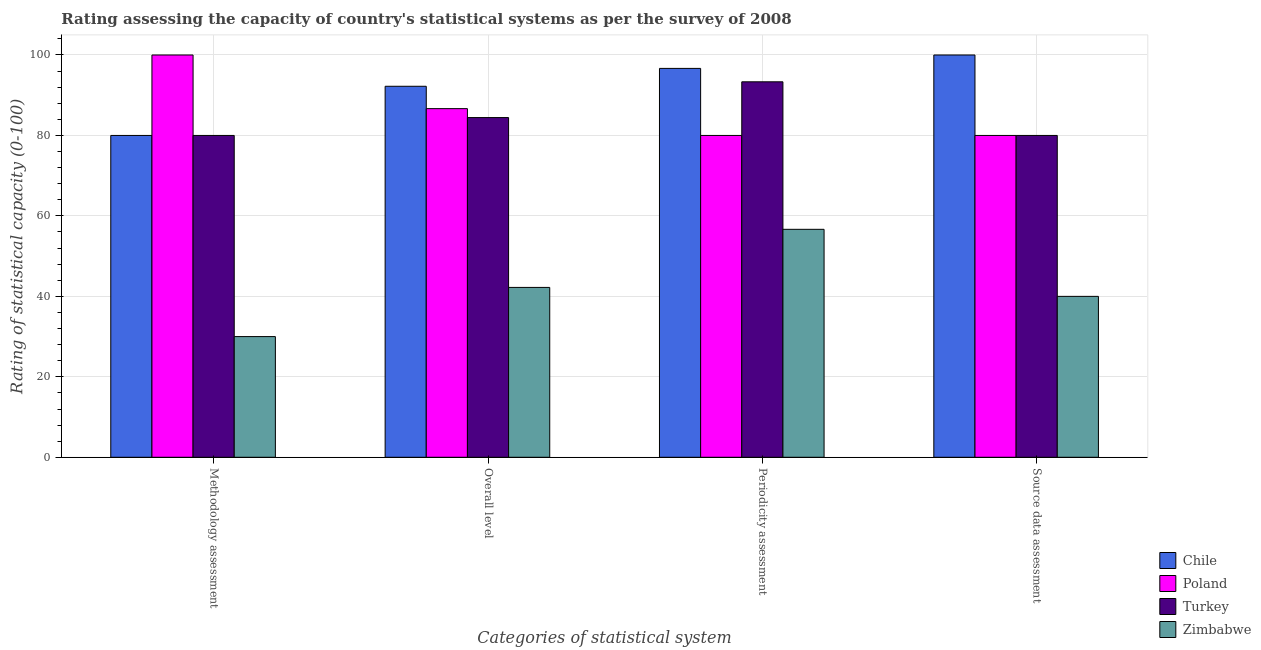How many different coloured bars are there?
Your answer should be compact. 4. How many groups of bars are there?
Your answer should be compact. 4. Are the number of bars on each tick of the X-axis equal?
Offer a very short reply. Yes. How many bars are there on the 4th tick from the left?
Your answer should be compact. 4. How many bars are there on the 1st tick from the right?
Make the answer very short. 4. What is the label of the 2nd group of bars from the left?
Your answer should be very brief. Overall level. What is the overall level rating in Chile?
Offer a terse response. 92.22. Across all countries, what is the maximum source data assessment rating?
Make the answer very short. 100. Across all countries, what is the minimum periodicity assessment rating?
Give a very brief answer. 56.67. In which country was the methodology assessment rating maximum?
Provide a succinct answer. Poland. In which country was the periodicity assessment rating minimum?
Your answer should be very brief. Zimbabwe. What is the total periodicity assessment rating in the graph?
Provide a short and direct response. 326.67. What is the difference between the periodicity assessment rating in Poland and that in Turkey?
Ensure brevity in your answer.  -13.33. What is the average methodology assessment rating per country?
Offer a very short reply. 72.5. What is the difference between the periodicity assessment rating and overall level rating in Chile?
Provide a succinct answer. 4.44. What is the ratio of the overall level rating in Chile to that in Zimbabwe?
Your response must be concise. 2.18. Is the difference between the periodicity assessment rating in Chile and Turkey greater than the difference between the source data assessment rating in Chile and Turkey?
Offer a terse response. No. What is the difference between the highest and the lowest methodology assessment rating?
Offer a terse response. 70. Is it the case that in every country, the sum of the overall level rating and source data assessment rating is greater than the sum of methodology assessment rating and periodicity assessment rating?
Provide a short and direct response. No. What does the 2nd bar from the left in Source data assessment represents?
Your answer should be very brief. Poland. What does the 3rd bar from the right in Periodicity assessment represents?
Your answer should be very brief. Poland. Is it the case that in every country, the sum of the methodology assessment rating and overall level rating is greater than the periodicity assessment rating?
Your answer should be compact. Yes. How many bars are there?
Your response must be concise. 16. Are all the bars in the graph horizontal?
Your answer should be very brief. No. How many countries are there in the graph?
Provide a short and direct response. 4. What is the difference between two consecutive major ticks on the Y-axis?
Your answer should be compact. 20. How are the legend labels stacked?
Keep it short and to the point. Vertical. What is the title of the graph?
Offer a terse response. Rating assessing the capacity of country's statistical systems as per the survey of 2008 . What is the label or title of the X-axis?
Make the answer very short. Categories of statistical system. What is the label or title of the Y-axis?
Offer a terse response. Rating of statistical capacity (0-100). What is the Rating of statistical capacity (0-100) of Chile in Methodology assessment?
Provide a short and direct response. 80. What is the Rating of statistical capacity (0-100) in Zimbabwe in Methodology assessment?
Give a very brief answer. 30. What is the Rating of statistical capacity (0-100) of Chile in Overall level?
Provide a short and direct response. 92.22. What is the Rating of statistical capacity (0-100) of Poland in Overall level?
Your answer should be compact. 86.67. What is the Rating of statistical capacity (0-100) in Turkey in Overall level?
Provide a succinct answer. 84.44. What is the Rating of statistical capacity (0-100) in Zimbabwe in Overall level?
Offer a very short reply. 42.22. What is the Rating of statistical capacity (0-100) in Chile in Periodicity assessment?
Provide a short and direct response. 96.67. What is the Rating of statistical capacity (0-100) of Turkey in Periodicity assessment?
Your answer should be compact. 93.33. What is the Rating of statistical capacity (0-100) of Zimbabwe in Periodicity assessment?
Make the answer very short. 56.67. What is the Rating of statistical capacity (0-100) of Chile in Source data assessment?
Keep it short and to the point. 100. What is the Rating of statistical capacity (0-100) in Turkey in Source data assessment?
Keep it short and to the point. 80. Across all Categories of statistical system, what is the maximum Rating of statistical capacity (0-100) of Chile?
Your response must be concise. 100. Across all Categories of statistical system, what is the maximum Rating of statistical capacity (0-100) of Poland?
Ensure brevity in your answer.  100. Across all Categories of statistical system, what is the maximum Rating of statistical capacity (0-100) in Turkey?
Offer a very short reply. 93.33. Across all Categories of statistical system, what is the maximum Rating of statistical capacity (0-100) in Zimbabwe?
Offer a terse response. 56.67. Across all Categories of statistical system, what is the minimum Rating of statistical capacity (0-100) in Turkey?
Provide a succinct answer. 80. What is the total Rating of statistical capacity (0-100) in Chile in the graph?
Provide a short and direct response. 368.89. What is the total Rating of statistical capacity (0-100) in Poland in the graph?
Provide a short and direct response. 346.67. What is the total Rating of statistical capacity (0-100) of Turkey in the graph?
Offer a terse response. 337.78. What is the total Rating of statistical capacity (0-100) of Zimbabwe in the graph?
Your answer should be very brief. 168.89. What is the difference between the Rating of statistical capacity (0-100) of Chile in Methodology assessment and that in Overall level?
Provide a succinct answer. -12.22. What is the difference between the Rating of statistical capacity (0-100) in Poland in Methodology assessment and that in Overall level?
Ensure brevity in your answer.  13.33. What is the difference between the Rating of statistical capacity (0-100) in Turkey in Methodology assessment and that in Overall level?
Your answer should be very brief. -4.44. What is the difference between the Rating of statistical capacity (0-100) of Zimbabwe in Methodology assessment and that in Overall level?
Your response must be concise. -12.22. What is the difference between the Rating of statistical capacity (0-100) in Chile in Methodology assessment and that in Periodicity assessment?
Provide a short and direct response. -16.67. What is the difference between the Rating of statistical capacity (0-100) of Turkey in Methodology assessment and that in Periodicity assessment?
Keep it short and to the point. -13.33. What is the difference between the Rating of statistical capacity (0-100) in Zimbabwe in Methodology assessment and that in Periodicity assessment?
Your answer should be compact. -26.67. What is the difference between the Rating of statistical capacity (0-100) in Chile in Methodology assessment and that in Source data assessment?
Make the answer very short. -20. What is the difference between the Rating of statistical capacity (0-100) of Poland in Methodology assessment and that in Source data assessment?
Provide a short and direct response. 20. What is the difference between the Rating of statistical capacity (0-100) of Chile in Overall level and that in Periodicity assessment?
Provide a short and direct response. -4.44. What is the difference between the Rating of statistical capacity (0-100) in Turkey in Overall level and that in Periodicity assessment?
Your answer should be compact. -8.89. What is the difference between the Rating of statistical capacity (0-100) of Zimbabwe in Overall level and that in Periodicity assessment?
Provide a short and direct response. -14.44. What is the difference between the Rating of statistical capacity (0-100) in Chile in Overall level and that in Source data assessment?
Provide a succinct answer. -7.78. What is the difference between the Rating of statistical capacity (0-100) in Turkey in Overall level and that in Source data assessment?
Offer a very short reply. 4.44. What is the difference between the Rating of statistical capacity (0-100) in Zimbabwe in Overall level and that in Source data assessment?
Keep it short and to the point. 2.22. What is the difference between the Rating of statistical capacity (0-100) in Chile in Periodicity assessment and that in Source data assessment?
Keep it short and to the point. -3.33. What is the difference between the Rating of statistical capacity (0-100) of Poland in Periodicity assessment and that in Source data assessment?
Provide a short and direct response. 0. What is the difference between the Rating of statistical capacity (0-100) in Turkey in Periodicity assessment and that in Source data assessment?
Provide a succinct answer. 13.33. What is the difference between the Rating of statistical capacity (0-100) in Zimbabwe in Periodicity assessment and that in Source data assessment?
Provide a succinct answer. 16.67. What is the difference between the Rating of statistical capacity (0-100) in Chile in Methodology assessment and the Rating of statistical capacity (0-100) in Poland in Overall level?
Provide a succinct answer. -6.67. What is the difference between the Rating of statistical capacity (0-100) in Chile in Methodology assessment and the Rating of statistical capacity (0-100) in Turkey in Overall level?
Ensure brevity in your answer.  -4.44. What is the difference between the Rating of statistical capacity (0-100) in Chile in Methodology assessment and the Rating of statistical capacity (0-100) in Zimbabwe in Overall level?
Provide a succinct answer. 37.78. What is the difference between the Rating of statistical capacity (0-100) in Poland in Methodology assessment and the Rating of statistical capacity (0-100) in Turkey in Overall level?
Offer a very short reply. 15.56. What is the difference between the Rating of statistical capacity (0-100) in Poland in Methodology assessment and the Rating of statistical capacity (0-100) in Zimbabwe in Overall level?
Your answer should be very brief. 57.78. What is the difference between the Rating of statistical capacity (0-100) in Turkey in Methodology assessment and the Rating of statistical capacity (0-100) in Zimbabwe in Overall level?
Your response must be concise. 37.78. What is the difference between the Rating of statistical capacity (0-100) in Chile in Methodology assessment and the Rating of statistical capacity (0-100) in Poland in Periodicity assessment?
Your answer should be very brief. 0. What is the difference between the Rating of statistical capacity (0-100) of Chile in Methodology assessment and the Rating of statistical capacity (0-100) of Turkey in Periodicity assessment?
Keep it short and to the point. -13.33. What is the difference between the Rating of statistical capacity (0-100) in Chile in Methodology assessment and the Rating of statistical capacity (0-100) in Zimbabwe in Periodicity assessment?
Your response must be concise. 23.33. What is the difference between the Rating of statistical capacity (0-100) in Poland in Methodology assessment and the Rating of statistical capacity (0-100) in Turkey in Periodicity assessment?
Give a very brief answer. 6.67. What is the difference between the Rating of statistical capacity (0-100) in Poland in Methodology assessment and the Rating of statistical capacity (0-100) in Zimbabwe in Periodicity assessment?
Give a very brief answer. 43.33. What is the difference between the Rating of statistical capacity (0-100) in Turkey in Methodology assessment and the Rating of statistical capacity (0-100) in Zimbabwe in Periodicity assessment?
Give a very brief answer. 23.33. What is the difference between the Rating of statistical capacity (0-100) in Chile in Methodology assessment and the Rating of statistical capacity (0-100) in Poland in Source data assessment?
Provide a short and direct response. 0. What is the difference between the Rating of statistical capacity (0-100) of Chile in Methodology assessment and the Rating of statistical capacity (0-100) of Turkey in Source data assessment?
Make the answer very short. 0. What is the difference between the Rating of statistical capacity (0-100) of Poland in Methodology assessment and the Rating of statistical capacity (0-100) of Turkey in Source data assessment?
Offer a terse response. 20. What is the difference between the Rating of statistical capacity (0-100) of Poland in Methodology assessment and the Rating of statistical capacity (0-100) of Zimbabwe in Source data assessment?
Your response must be concise. 60. What is the difference between the Rating of statistical capacity (0-100) in Chile in Overall level and the Rating of statistical capacity (0-100) in Poland in Periodicity assessment?
Ensure brevity in your answer.  12.22. What is the difference between the Rating of statistical capacity (0-100) in Chile in Overall level and the Rating of statistical capacity (0-100) in Turkey in Periodicity assessment?
Your answer should be compact. -1.11. What is the difference between the Rating of statistical capacity (0-100) of Chile in Overall level and the Rating of statistical capacity (0-100) of Zimbabwe in Periodicity assessment?
Offer a very short reply. 35.56. What is the difference between the Rating of statistical capacity (0-100) in Poland in Overall level and the Rating of statistical capacity (0-100) in Turkey in Periodicity assessment?
Provide a short and direct response. -6.67. What is the difference between the Rating of statistical capacity (0-100) in Poland in Overall level and the Rating of statistical capacity (0-100) in Zimbabwe in Periodicity assessment?
Offer a terse response. 30. What is the difference between the Rating of statistical capacity (0-100) in Turkey in Overall level and the Rating of statistical capacity (0-100) in Zimbabwe in Periodicity assessment?
Offer a very short reply. 27.78. What is the difference between the Rating of statistical capacity (0-100) in Chile in Overall level and the Rating of statistical capacity (0-100) in Poland in Source data assessment?
Your response must be concise. 12.22. What is the difference between the Rating of statistical capacity (0-100) in Chile in Overall level and the Rating of statistical capacity (0-100) in Turkey in Source data assessment?
Provide a short and direct response. 12.22. What is the difference between the Rating of statistical capacity (0-100) in Chile in Overall level and the Rating of statistical capacity (0-100) in Zimbabwe in Source data assessment?
Your answer should be very brief. 52.22. What is the difference between the Rating of statistical capacity (0-100) in Poland in Overall level and the Rating of statistical capacity (0-100) in Turkey in Source data assessment?
Keep it short and to the point. 6.67. What is the difference between the Rating of statistical capacity (0-100) of Poland in Overall level and the Rating of statistical capacity (0-100) of Zimbabwe in Source data assessment?
Ensure brevity in your answer.  46.67. What is the difference between the Rating of statistical capacity (0-100) of Turkey in Overall level and the Rating of statistical capacity (0-100) of Zimbabwe in Source data assessment?
Ensure brevity in your answer.  44.44. What is the difference between the Rating of statistical capacity (0-100) of Chile in Periodicity assessment and the Rating of statistical capacity (0-100) of Poland in Source data assessment?
Give a very brief answer. 16.67. What is the difference between the Rating of statistical capacity (0-100) in Chile in Periodicity assessment and the Rating of statistical capacity (0-100) in Turkey in Source data assessment?
Your response must be concise. 16.67. What is the difference between the Rating of statistical capacity (0-100) of Chile in Periodicity assessment and the Rating of statistical capacity (0-100) of Zimbabwe in Source data assessment?
Your answer should be compact. 56.67. What is the difference between the Rating of statistical capacity (0-100) of Poland in Periodicity assessment and the Rating of statistical capacity (0-100) of Turkey in Source data assessment?
Provide a succinct answer. 0. What is the difference between the Rating of statistical capacity (0-100) of Poland in Periodicity assessment and the Rating of statistical capacity (0-100) of Zimbabwe in Source data assessment?
Your answer should be compact. 40. What is the difference between the Rating of statistical capacity (0-100) in Turkey in Periodicity assessment and the Rating of statistical capacity (0-100) in Zimbabwe in Source data assessment?
Provide a succinct answer. 53.33. What is the average Rating of statistical capacity (0-100) of Chile per Categories of statistical system?
Your answer should be very brief. 92.22. What is the average Rating of statistical capacity (0-100) of Poland per Categories of statistical system?
Keep it short and to the point. 86.67. What is the average Rating of statistical capacity (0-100) in Turkey per Categories of statistical system?
Ensure brevity in your answer.  84.44. What is the average Rating of statistical capacity (0-100) of Zimbabwe per Categories of statistical system?
Your answer should be very brief. 42.22. What is the difference between the Rating of statistical capacity (0-100) in Chile and Rating of statistical capacity (0-100) in Turkey in Methodology assessment?
Ensure brevity in your answer.  0. What is the difference between the Rating of statistical capacity (0-100) of Chile and Rating of statistical capacity (0-100) of Zimbabwe in Methodology assessment?
Provide a succinct answer. 50. What is the difference between the Rating of statistical capacity (0-100) of Chile and Rating of statistical capacity (0-100) of Poland in Overall level?
Provide a succinct answer. 5.56. What is the difference between the Rating of statistical capacity (0-100) in Chile and Rating of statistical capacity (0-100) in Turkey in Overall level?
Your answer should be very brief. 7.78. What is the difference between the Rating of statistical capacity (0-100) of Chile and Rating of statistical capacity (0-100) of Zimbabwe in Overall level?
Make the answer very short. 50. What is the difference between the Rating of statistical capacity (0-100) of Poland and Rating of statistical capacity (0-100) of Turkey in Overall level?
Your answer should be very brief. 2.22. What is the difference between the Rating of statistical capacity (0-100) in Poland and Rating of statistical capacity (0-100) in Zimbabwe in Overall level?
Give a very brief answer. 44.44. What is the difference between the Rating of statistical capacity (0-100) of Turkey and Rating of statistical capacity (0-100) of Zimbabwe in Overall level?
Your response must be concise. 42.22. What is the difference between the Rating of statistical capacity (0-100) of Chile and Rating of statistical capacity (0-100) of Poland in Periodicity assessment?
Make the answer very short. 16.67. What is the difference between the Rating of statistical capacity (0-100) in Poland and Rating of statistical capacity (0-100) in Turkey in Periodicity assessment?
Ensure brevity in your answer.  -13.33. What is the difference between the Rating of statistical capacity (0-100) in Poland and Rating of statistical capacity (0-100) in Zimbabwe in Periodicity assessment?
Offer a very short reply. 23.33. What is the difference between the Rating of statistical capacity (0-100) of Turkey and Rating of statistical capacity (0-100) of Zimbabwe in Periodicity assessment?
Provide a succinct answer. 36.67. What is the difference between the Rating of statistical capacity (0-100) in Chile and Rating of statistical capacity (0-100) in Poland in Source data assessment?
Keep it short and to the point. 20. What is the difference between the Rating of statistical capacity (0-100) of Poland and Rating of statistical capacity (0-100) of Turkey in Source data assessment?
Offer a very short reply. 0. What is the ratio of the Rating of statistical capacity (0-100) in Chile in Methodology assessment to that in Overall level?
Make the answer very short. 0.87. What is the ratio of the Rating of statistical capacity (0-100) of Poland in Methodology assessment to that in Overall level?
Make the answer very short. 1.15. What is the ratio of the Rating of statistical capacity (0-100) in Turkey in Methodology assessment to that in Overall level?
Give a very brief answer. 0.95. What is the ratio of the Rating of statistical capacity (0-100) of Zimbabwe in Methodology assessment to that in Overall level?
Your answer should be very brief. 0.71. What is the ratio of the Rating of statistical capacity (0-100) of Chile in Methodology assessment to that in Periodicity assessment?
Your response must be concise. 0.83. What is the ratio of the Rating of statistical capacity (0-100) in Zimbabwe in Methodology assessment to that in Periodicity assessment?
Offer a very short reply. 0.53. What is the ratio of the Rating of statistical capacity (0-100) of Chile in Methodology assessment to that in Source data assessment?
Provide a succinct answer. 0.8. What is the ratio of the Rating of statistical capacity (0-100) of Zimbabwe in Methodology assessment to that in Source data assessment?
Provide a short and direct response. 0.75. What is the ratio of the Rating of statistical capacity (0-100) in Chile in Overall level to that in Periodicity assessment?
Keep it short and to the point. 0.95. What is the ratio of the Rating of statistical capacity (0-100) of Poland in Overall level to that in Periodicity assessment?
Provide a succinct answer. 1.08. What is the ratio of the Rating of statistical capacity (0-100) in Turkey in Overall level to that in Periodicity assessment?
Your response must be concise. 0.9. What is the ratio of the Rating of statistical capacity (0-100) of Zimbabwe in Overall level to that in Periodicity assessment?
Make the answer very short. 0.75. What is the ratio of the Rating of statistical capacity (0-100) in Chile in Overall level to that in Source data assessment?
Provide a succinct answer. 0.92. What is the ratio of the Rating of statistical capacity (0-100) of Poland in Overall level to that in Source data assessment?
Ensure brevity in your answer.  1.08. What is the ratio of the Rating of statistical capacity (0-100) of Turkey in Overall level to that in Source data assessment?
Provide a succinct answer. 1.06. What is the ratio of the Rating of statistical capacity (0-100) in Zimbabwe in Overall level to that in Source data assessment?
Give a very brief answer. 1.06. What is the ratio of the Rating of statistical capacity (0-100) in Chile in Periodicity assessment to that in Source data assessment?
Your response must be concise. 0.97. What is the ratio of the Rating of statistical capacity (0-100) of Poland in Periodicity assessment to that in Source data assessment?
Your answer should be very brief. 1. What is the ratio of the Rating of statistical capacity (0-100) of Zimbabwe in Periodicity assessment to that in Source data assessment?
Make the answer very short. 1.42. What is the difference between the highest and the second highest Rating of statistical capacity (0-100) of Poland?
Your answer should be very brief. 13.33. What is the difference between the highest and the second highest Rating of statistical capacity (0-100) of Turkey?
Your answer should be very brief. 8.89. What is the difference between the highest and the second highest Rating of statistical capacity (0-100) in Zimbabwe?
Give a very brief answer. 14.44. What is the difference between the highest and the lowest Rating of statistical capacity (0-100) of Turkey?
Ensure brevity in your answer.  13.33. What is the difference between the highest and the lowest Rating of statistical capacity (0-100) of Zimbabwe?
Keep it short and to the point. 26.67. 